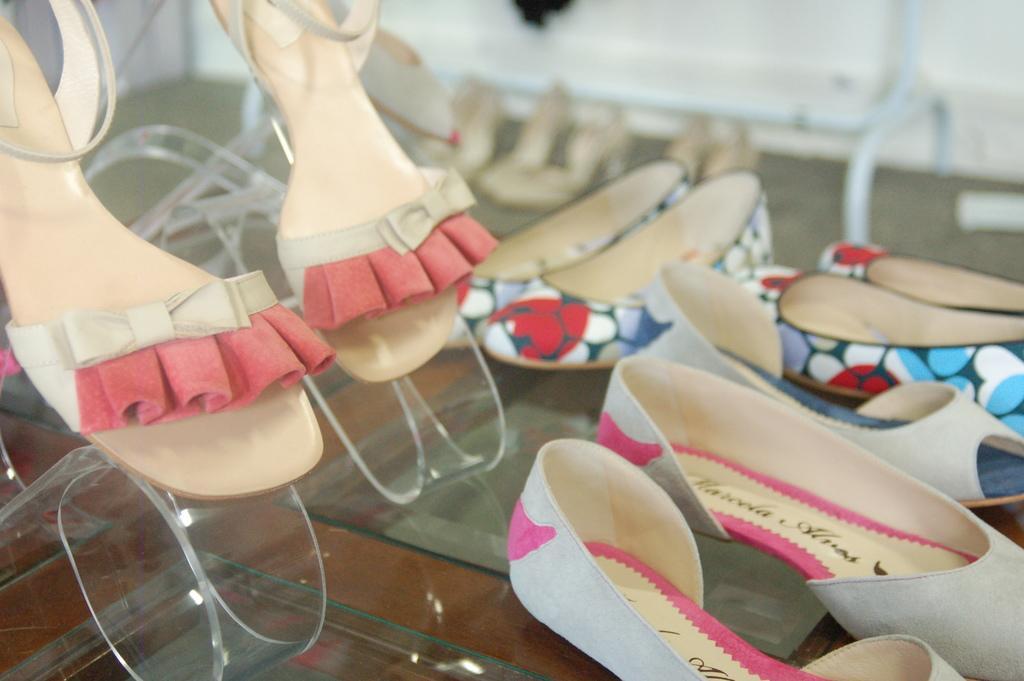How would you summarize this image in a sentence or two? In the image we can see there are shoes and sandals which are kept on shoe stand. 